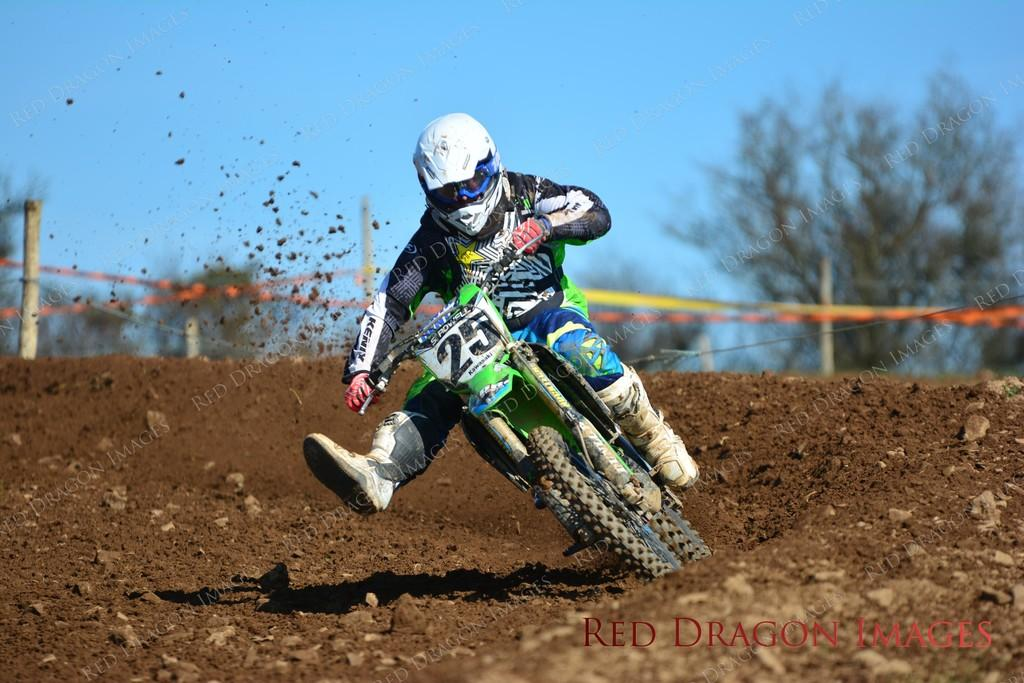<image>
Present a compact description of the photo's key features. A man riding a bike has plate number 25 on his handlebars. 